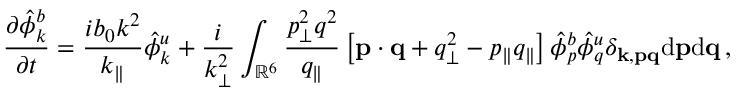Convert formula to latex. <formula><loc_0><loc_0><loc_500><loc_500>{ \frac { \partial \hat { \phi } _ { k } ^ { b } } { \partial t } } = \frac { i b _ { 0 } k ^ { 2 } } { k _ { \| } } \hat { \phi } _ { k } ^ { u } + \frac { i } { k _ { \perp } ^ { 2 } } \int _ { \mathbb { R } ^ { 6 } } \frac { p _ { \perp } ^ { 2 } q ^ { 2 } } { q _ { \| } } \left [ { p } \cdot { q } + q _ { \perp } ^ { 2 } - p _ { \| } q _ { \| } \right ] \hat { \phi } _ { p } ^ { b } \hat { \phi } _ { q } ^ { u } \delta _ { { k } , { p } { q } } d { p } d { q } \, ,</formula> 